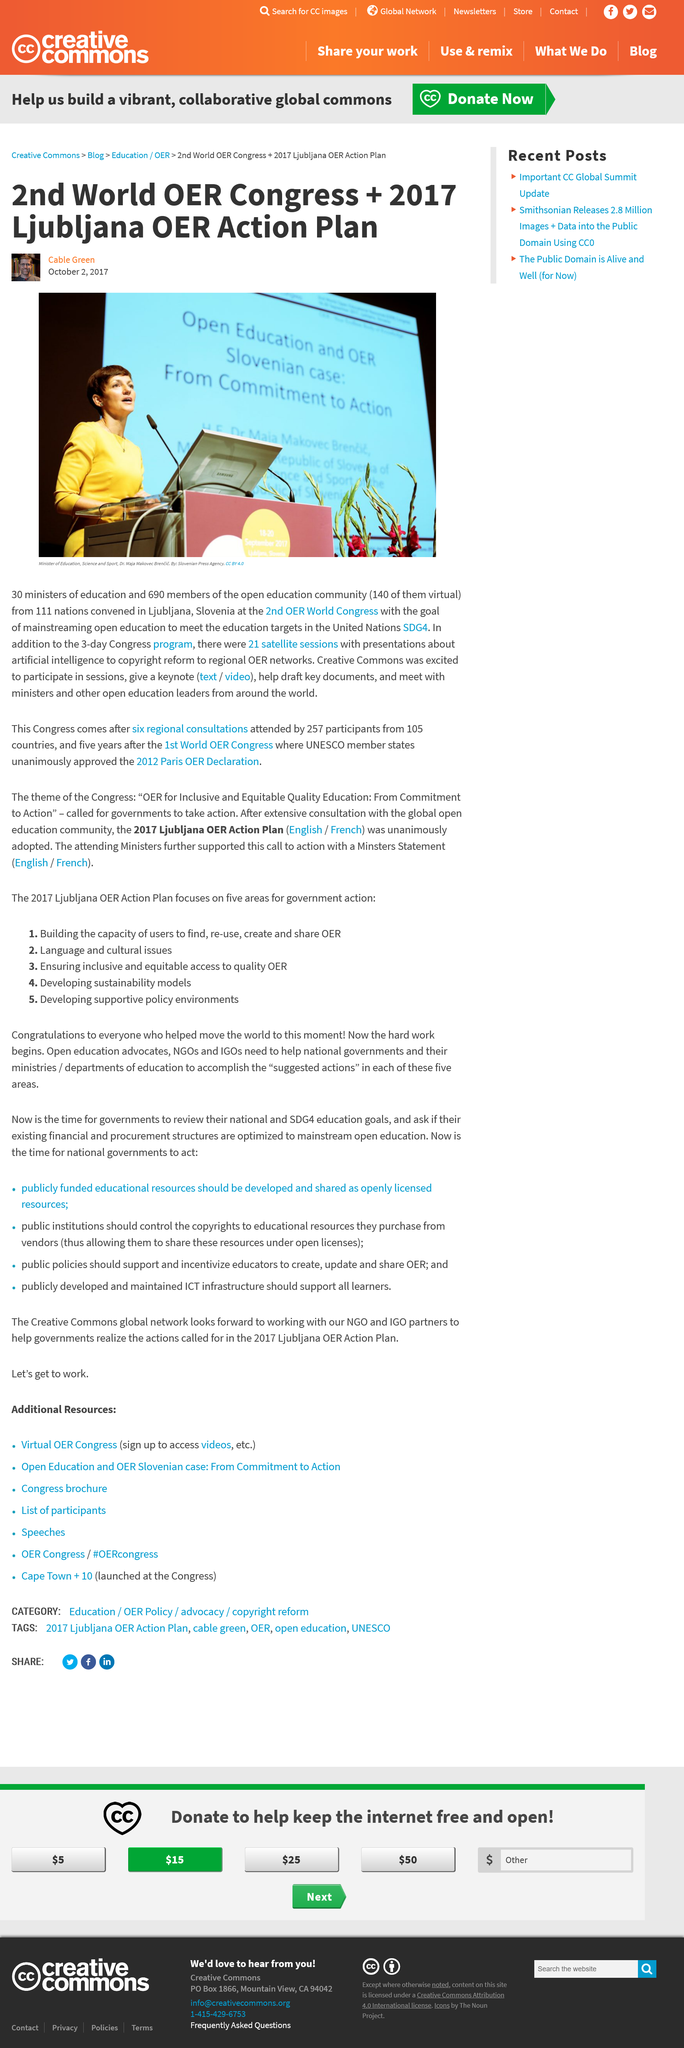Point out several critical features in this image. Thirty ministers of education attended the 2nd OER World Congress. One hundred and eleven nations participated in the 2nd OER World Congress held in Ljubljana, Slovenia. The 2nd OER World Congress aimed to promote the widespread adoption of open education in order to achieve the education-related goals outlined in the United Nations' Sustainable Development Goal 4. 